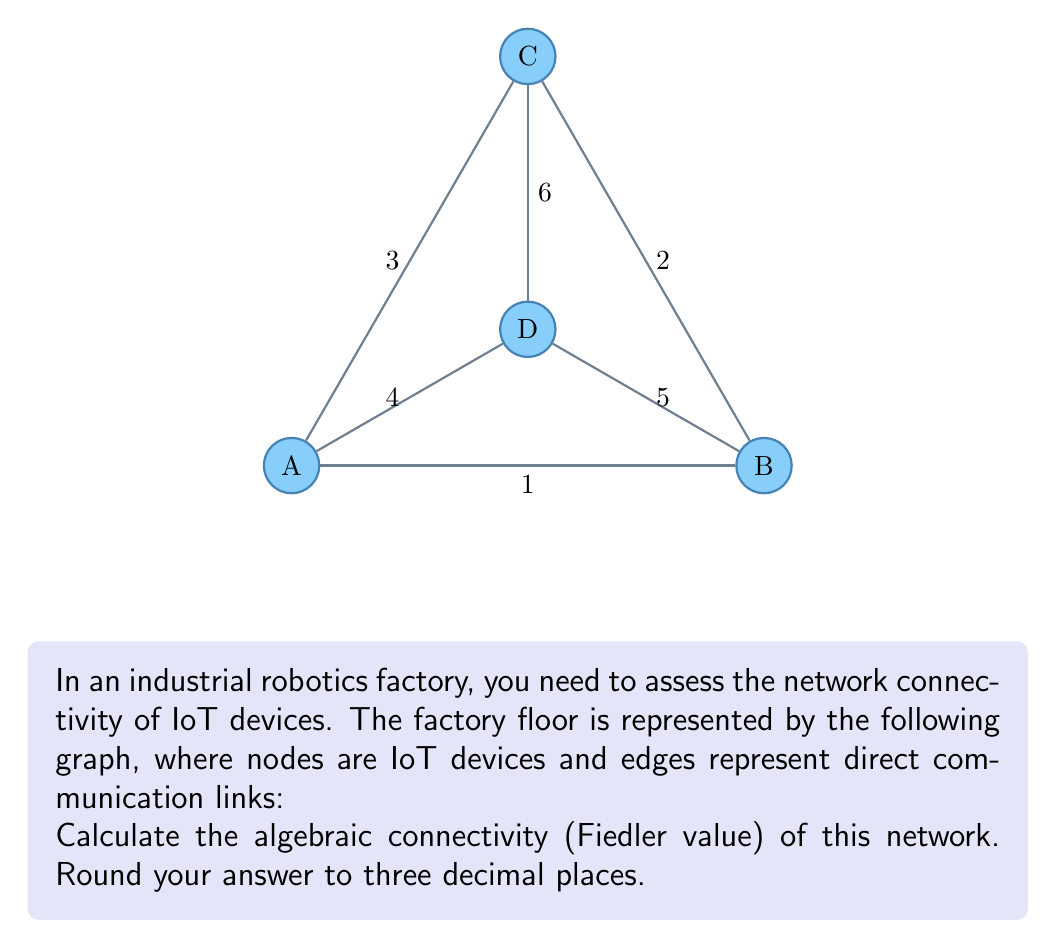Show me your answer to this math problem. To calculate the algebraic connectivity, we follow these steps:

1) First, construct the adjacency matrix A:
   $$A = \begin{bmatrix}
   0 & 1 & 1 & 1 \\
   1 & 0 & 1 & 1 \\
   1 & 1 & 0 & 1 \\
   1 & 1 & 1 & 0
   \end{bmatrix}$$

2) Calculate the degree matrix D:
   $$D = \begin{bmatrix}
   3 & 0 & 0 & 0 \\
   0 & 3 & 0 & 0 \\
   0 & 0 & 3 & 0 \\
   0 & 0 & 0 & 3
   \end{bmatrix}$$

3) Compute the Laplacian matrix L = D - A:
   $$L = \begin{bmatrix}
   3 & -1 & -1 & -1 \\
   -1 & 3 & -1 & -1 \\
   -1 & -1 & 3 & -1 \\
   -1 & -1 & -1 & 3
   \end{bmatrix}$$

4) Calculate the eigenvalues of L. The characteristic equation is:
   $$det(L - \lambda I) = (\lambda - 4)^3(\lambda - 0) = 0$$

5) The eigenvalues are: $\lambda_1 = 0, \lambda_2 = \lambda_3 = \lambda_4 = 4$

6) The algebraic connectivity (Fiedler value) is the second smallest eigenvalue:
   $$\lambda_2 = 4$$

7) Rounding to three decimal places: 4.000

This high algebraic connectivity indicates a well-connected network, which is beneficial for efficient communication between IoT devices in the factory setting.
Answer: 4.000 